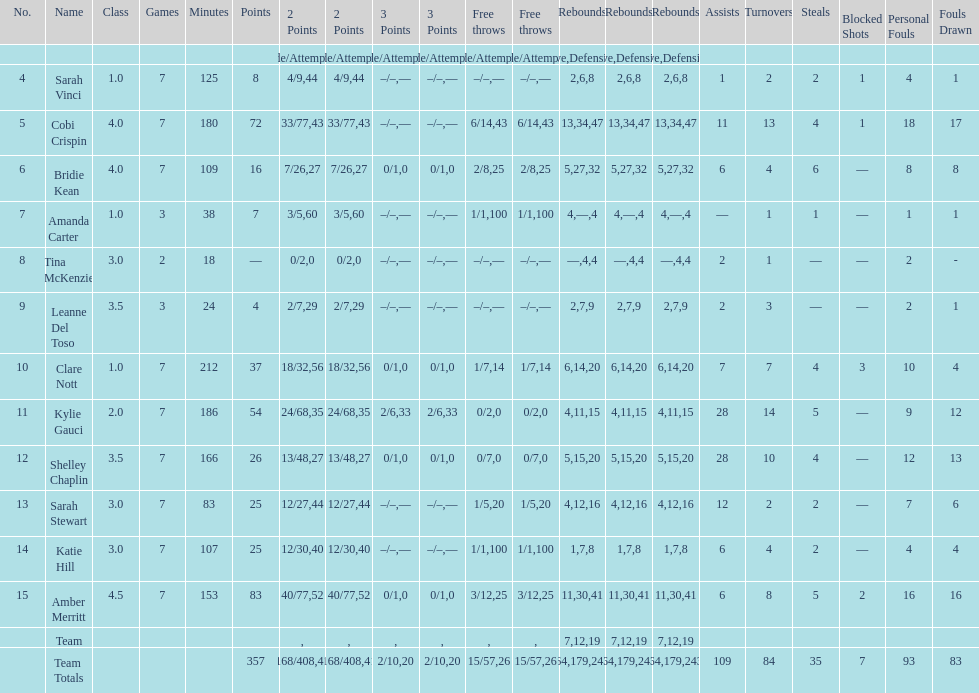Which player played in the least games? Tina McKenzie. Could you parse the entire table? {'header': ['No.', 'Name', 'Class', 'Games', 'Minutes', 'Points', '2 Points', '2 Points', '3 Points', '3 Points', 'Free throws', 'Free throws', 'Rebounds', 'Rebounds', 'Rebounds', 'Assists', 'Turnovers', 'Steals', 'Blocked Shots', 'Personal Fouls', 'Fouls Drawn'], 'rows': [['', '', '', '', '', '', 'Made/Attempts', '%', 'Made/Attempts', '%', 'Made/Attempts', '%', 'Offensive', 'Defensive', 'Total', '', '', '', '', '', ''], ['4', 'Sarah Vinci', '1.0', '7', '125', '8', '4/9', '44', '–/–', '—', '–/–', '—', '2', '6', '8', '1', '2', '2', '1', '4', '1'], ['5', 'Cobi Crispin', '4.0', '7', '180', '72', '33/77', '43', '–/–', '—', '6/14', '43', '13', '34', '47', '11', '13', '4', '1', '18', '17'], ['6', 'Bridie Kean', '4.0', '7', '109', '16', '7/26', '27', '0/1', '0', '2/8', '25', '5', '27', '32', '6', '4', '6', '—', '8', '8'], ['7', 'Amanda Carter', '1.0', '3', '38', '7', '3/5', '60', '–/–', '—', '1/1', '100', '4', '—', '4', '—', '1', '1', '—', '1', '1'], ['8', 'Tina McKenzie', '3.0', '2', '18', '—', '0/2', '0', '–/–', '—', '–/–', '—', '—', '4', '4', '2', '1', '—', '—', '2', '-'], ['9', 'Leanne Del Toso', '3.5', '3', '24', '4', '2/7', '29', '–/–', '—', '–/–', '—', '2', '7', '9', '2', '3', '—', '—', '2', '1'], ['10', 'Clare Nott', '1.0', '7', '212', '37', '18/32', '56', '0/1', '0', '1/7', '14', '6', '14', '20', '7', '7', '4', '3', '10', '4'], ['11', 'Kylie Gauci', '2.0', '7', '186', '54', '24/68', '35', '2/6', '33', '0/2', '0', '4', '11', '15', '28', '14', '5', '—', '9', '12'], ['12', 'Shelley Chaplin', '3.5', '7', '166', '26', '13/48', '27', '0/1', '0', '0/7', '0', '5', '15', '20', '28', '10', '4', '—', '12', '13'], ['13', 'Sarah Stewart', '3.0', '7', '83', '25', '12/27', '44', '–/–', '—', '1/5', '20', '4', '12', '16', '12', '2', '2', '—', '7', '6'], ['14', 'Katie Hill', '3.0', '7', '107', '25', '12/30', '40', '–/–', '—', '1/1', '100', '1', '7', '8', '6', '4', '2', '—', '4', '4'], ['15', 'Amber Merritt', '4.5', '7', '153', '83', '40/77', '52', '0/1', '0', '3/12', '25', '11', '30', '41', '6', '8', '5', '2', '16', '16'], ['', 'Team', '', '', '', '', '', '', '', '', '', '', '7', '12', '19', '', '', '', '', '', ''], ['', 'Team Totals', '', '', '', '357', '168/408', '41', '2/10', '20', '15/57', '26', '64', '179', '243', '109', '84', '35', '7', '93', '83']]} 